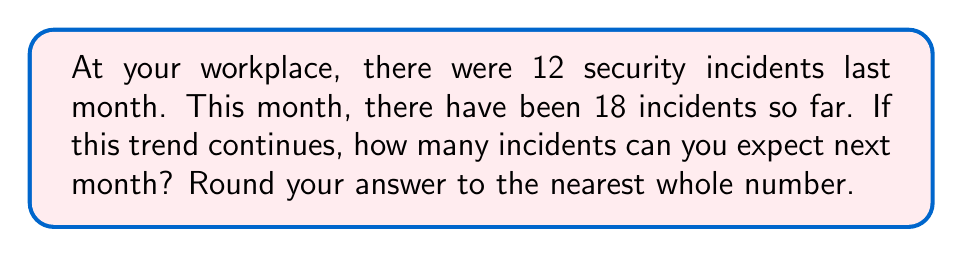Can you solve this math problem? To predict the number of incidents for next month, we need to analyze the pattern in the given data. Let's break it down step-by-step:

1. Last month's incidents: 12
2. This month's incidents: 18

To find the trend, we need to calculate the rate of increase:

$$ \text{Increase} = 18 - 12 = 6 $$

This means the number of incidents increased by 6 from last month to this month.

To calculate the rate of increase as a percentage:

$$ \text{Percentage increase} = \frac{\text{Increase}}{\text{Original number}} \times 100\% $$

$$ \text{Percentage increase} = \frac{6}{12} \times 100\% = 50\% $$

So, the number of incidents increased by 50% from last month to this month.

If this trend continues, we can expect another 50% increase for next month:

$$ \text{Expected incidents next month} = 18 \times (1 + 0.50) = 18 \times 1.50 = 27 $$

Therefore, if the trend continues, we can expect 27 incidents next month.
Answer: 27 incidents 